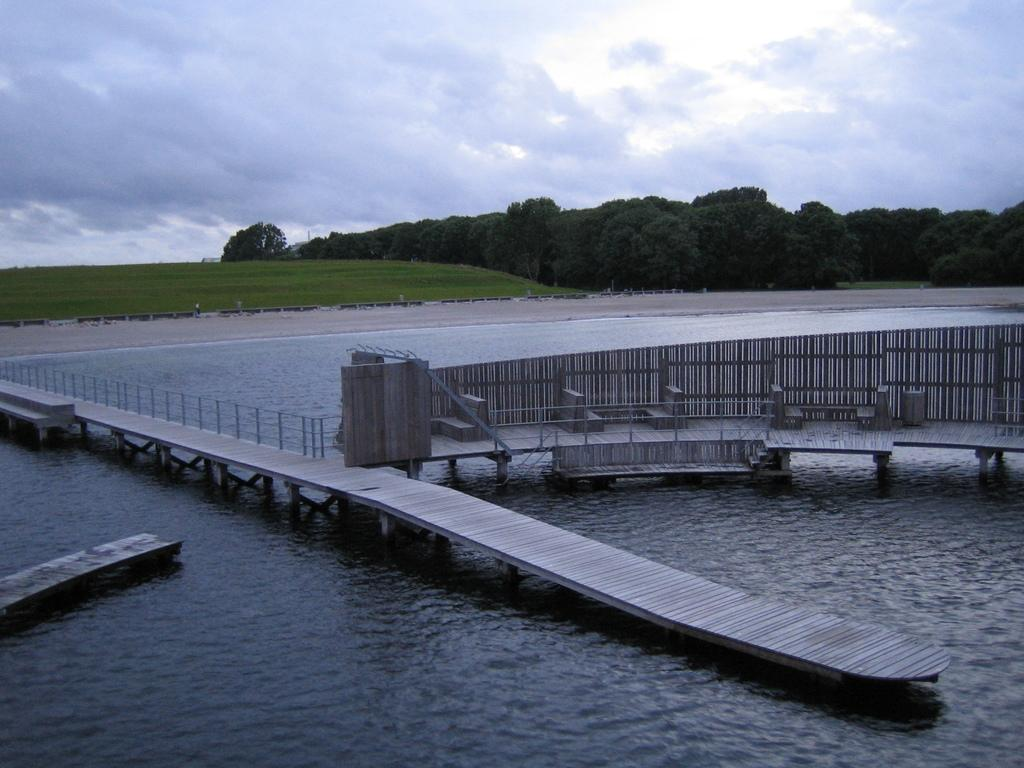What type of structure can be seen in the image? There is a bridge in the image. What type of seating is available in the image? There are benches on a platform in the image. What can be seen flowing beneath the bridge? There is water visible in the image. What type of vegetation is present in the background of the image? There is green grass and trees in the background of the image. What is visible in the sky in the background of the image? The sky is visible in the background of the image, and it appears to be cloudy. Where is the pocket located on the bridge in the image? There is no pocket present on the bridge in the image. What color is the crayon used to draw the trees in the background of the image? There is no crayon or drawing present in the image; the trees are depicted realistically. 